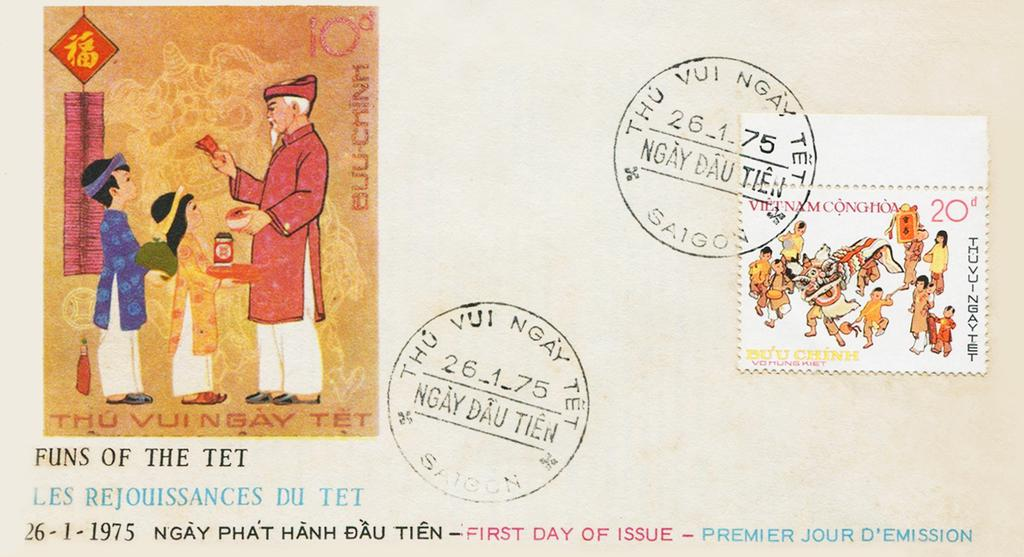<image>
Provide a brief description of the given image. A stamp with the text Thu vui  ngay tet at the bottom shows an old man and two children. 